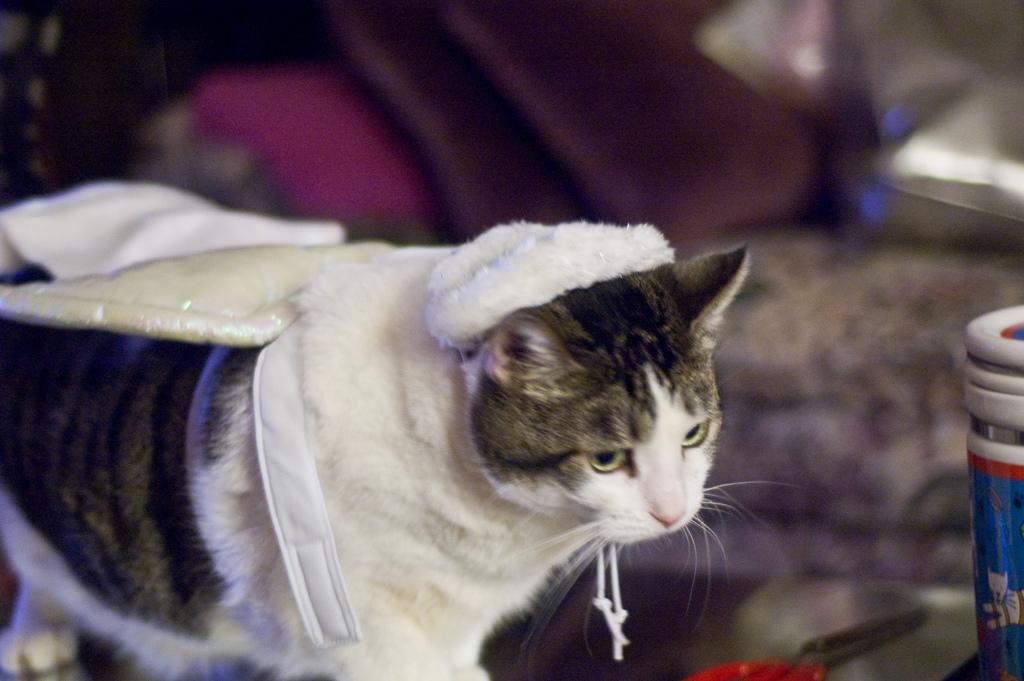What type of animal is in the image? There is a cat in the image. Can you describe the background of the image? The background of the image is blurry. What type of pencil can be seen on the wall in the image? There is no pencil or wall present in the image; it features a cat with a blurry background. 